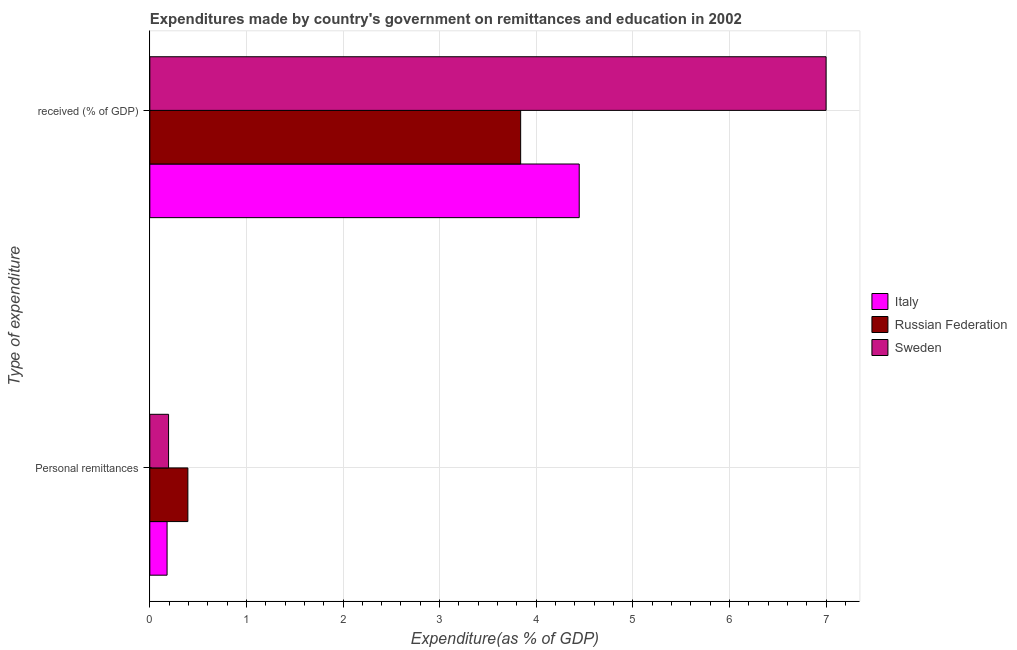How many different coloured bars are there?
Your answer should be compact. 3. Are the number of bars per tick equal to the number of legend labels?
Your answer should be very brief. Yes. Are the number of bars on each tick of the Y-axis equal?
Provide a short and direct response. Yes. What is the label of the 2nd group of bars from the top?
Your response must be concise. Personal remittances. What is the expenditure in personal remittances in Russian Federation?
Your answer should be compact. 0.39. Across all countries, what is the maximum expenditure in personal remittances?
Offer a terse response. 0.39. Across all countries, what is the minimum expenditure in education?
Your response must be concise. 3.84. In which country was the expenditure in personal remittances maximum?
Offer a very short reply. Russian Federation. In which country was the expenditure in education minimum?
Provide a short and direct response. Russian Federation. What is the total expenditure in education in the graph?
Make the answer very short. 15.29. What is the difference between the expenditure in personal remittances in Sweden and that in Italy?
Offer a terse response. 0.02. What is the difference between the expenditure in education in Italy and the expenditure in personal remittances in Sweden?
Keep it short and to the point. 4.25. What is the average expenditure in personal remittances per country?
Offer a terse response. 0.26. What is the difference between the expenditure in education and expenditure in personal remittances in Italy?
Ensure brevity in your answer.  4.27. What is the ratio of the expenditure in education in Russian Federation to that in Italy?
Your answer should be very brief. 0.86. What does the 3rd bar from the top in  received (% of GDP) represents?
Provide a short and direct response. Italy. What does the 2nd bar from the bottom in Personal remittances represents?
Make the answer very short. Russian Federation. How many countries are there in the graph?
Offer a very short reply. 3. Does the graph contain any zero values?
Keep it short and to the point. No. What is the title of the graph?
Make the answer very short. Expenditures made by country's government on remittances and education in 2002. Does "Moldova" appear as one of the legend labels in the graph?
Your answer should be very brief. No. What is the label or title of the X-axis?
Make the answer very short. Expenditure(as % of GDP). What is the label or title of the Y-axis?
Your answer should be very brief. Type of expenditure. What is the Expenditure(as % of GDP) of Italy in Personal remittances?
Offer a terse response. 0.18. What is the Expenditure(as % of GDP) in Russian Federation in Personal remittances?
Keep it short and to the point. 0.39. What is the Expenditure(as % of GDP) of Sweden in Personal remittances?
Give a very brief answer. 0.19. What is the Expenditure(as % of GDP) of Italy in  received (% of GDP)?
Ensure brevity in your answer.  4.45. What is the Expenditure(as % of GDP) of Russian Federation in  received (% of GDP)?
Your response must be concise. 3.84. What is the Expenditure(as % of GDP) of Sweden in  received (% of GDP)?
Keep it short and to the point. 7. Across all Type of expenditure, what is the maximum Expenditure(as % of GDP) of Italy?
Your answer should be very brief. 4.45. Across all Type of expenditure, what is the maximum Expenditure(as % of GDP) of Russian Federation?
Provide a succinct answer. 3.84. Across all Type of expenditure, what is the maximum Expenditure(as % of GDP) in Sweden?
Provide a succinct answer. 7. Across all Type of expenditure, what is the minimum Expenditure(as % of GDP) of Italy?
Keep it short and to the point. 0.18. Across all Type of expenditure, what is the minimum Expenditure(as % of GDP) of Russian Federation?
Make the answer very short. 0.39. Across all Type of expenditure, what is the minimum Expenditure(as % of GDP) in Sweden?
Ensure brevity in your answer.  0.19. What is the total Expenditure(as % of GDP) in Italy in the graph?
Make the answer very short. 4.62. What is the total Expenditure(as % of GDP) in Russian Federation in the graph?
Keep it short and to the point. 4.23. What is the total Expenditure(as % of GDP) of Sweden in the graph?
Ensure brevity in your answer.  7.2. What is the difference between the Expenditure(as % of GDP) in Italy in Personal remittances and that in  received (% of GDP)?
Ensure brevity in your answer.  -4.27. What is the difference between the Expenditure(as % of GDP) of Russian Federation in Personal remittances and that in  received (% of GDP)?
Offer a terse response. -3.45. What is the difference between the Expenditure(as % of GDP) in Sweden in Personal remittances and that in  received (% of GDP)?
Your response must be concise. -6.81. What is the difference between the Expenditure(as % of GDP) of Italy in Personal remittances and the Expenditure(as % of GDP) of Russian Federation in  received (% of GDP)?
Your answer should be compact. -3.66. What is the difference between the Expenditure(as % of GDP) in Italy in Personal remittances and the Expenditure(as % of GDP) in Sweden in  received (% of GDP)?
Ensure brevity in your answer.  -6.82. What is the difference between the Expenditure(as % of GDP) of Russian Federation in Personal remittances and the Expenditure(as % of GDP) of Sweden in  received (% of GDP)?
Your response must be concise. -6.61. What is the average Expenditure(as % of GDP) in Italy per Type of expenditure?
Offer a very short reply. 2.31. What is the average Expenditure(as % of GDP) of Russian Federation per Type of expenditure?
Keep it short and to the point. 2.12. What is the average Expenditure(as % of GDP) of Sweden per Type of expenditure?
Your response must be concise. 3.6. What is the difference between the Expenditure(as % of GDP) in Italy and Expenditure(as % of GDP) in Russian Federation in Personal remittances?
Your answer should be compact. -0.22. What is the difference between the Expenditure(as % of GDP) in Italy and Expenditure(as % of GDP) in Sweden in Personal remittances?
Provide a short and direct response. -0.02. What is the difference between the Expenditure(as % of GDP) in Russian Federation and Expenditure(as % of GDP) in Sweden in Personal remittances?
Your response must be concise. 0.2. What is the difference between the Expenditure(as % of GDP) of Italy and Expenditure(as % of GDP) of Russian Federation in  received (% of GDP)?
Give a very brief answer. 0.61. What is the difference between the Expenditure(as % of GDP) of Italy and Expenditure(as % of GDP) of Sweden in  received (% of GDP)?
Provide a succinct answer. -2.56. What is the difference between the Expenditure(as % of GDP) of Russian Federation and Expenditure(as % of GDP) of Sweden in  received (% of GDP)?
Make the answer very short. -3.16. What is the ratio of the Expenditure(as % of GDP) in Italy in Personal remittances to that in  received (% of GDP)?
Make the answer very short. 0.04. What is the ratio of the Expenditure(as % of GDP) of Russian Federation in Personal remittances to that in  received (% of GDP)?
Give a very brief answer. 0.1. What is the ratio of the Expenditure(as % of GDP) of Sweden in Personal remittances to that in  received (% of GDP)?
Offer a very short reply. 0.03. What is the difference between the highest and the second highest Expenditure(as % of GDP) in Italy?
Your response must be concise. 4.27. What is the difference between the highest and the second highest Expenditure(as % of GDP) in Russian Federation?
Offer a terse response. 3.45. What is the difference between the highest and the second highest Expenditure(as % of GDP) in Sweden?
Give a very brief answer. 6.81. What is the difference between the highest and the lowest Expenditure(as % of GDP) in Italy?
Your answer should be very brief. 4.27. What is the difference between the highest and the lowest Expenditure(as % of GDP) in Russian Federation?
Give a very brief answer. 3.45. What is the difference between the highest and the lowest Expenditure(as % of GDP) in Sweden?
Offer a very short reply. 6.81. 